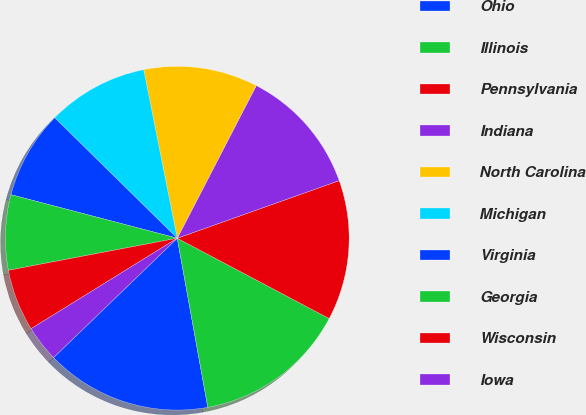Convert chart. <chart><loc_0><loc_0><loc_500><loc_500><pie_chart><fcel>Ohio<fcel>Illinois<fcel>Pennsylvania<fcel>Indiana<fcel>North Carolina<fcel>Michigan<fcel>Virginia<fcel>Georgia<fcel>Wisconsin<fcel>Iowa<nl><fcel>15.63%<fcel>14.41%<fcel>13.18%<fcel>11.96%<fcel>10.73%<fcel>9.51%<fcel>8.29%<fcel>7.06%<fcel>5.84%<fcel>3.39%<nl></chart> 